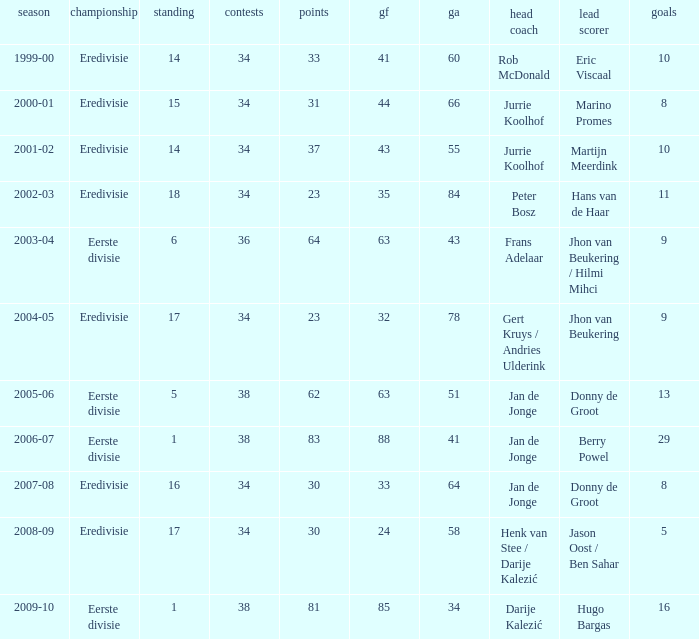Who is the manager whose rank is 16? Jan de Jonge. 